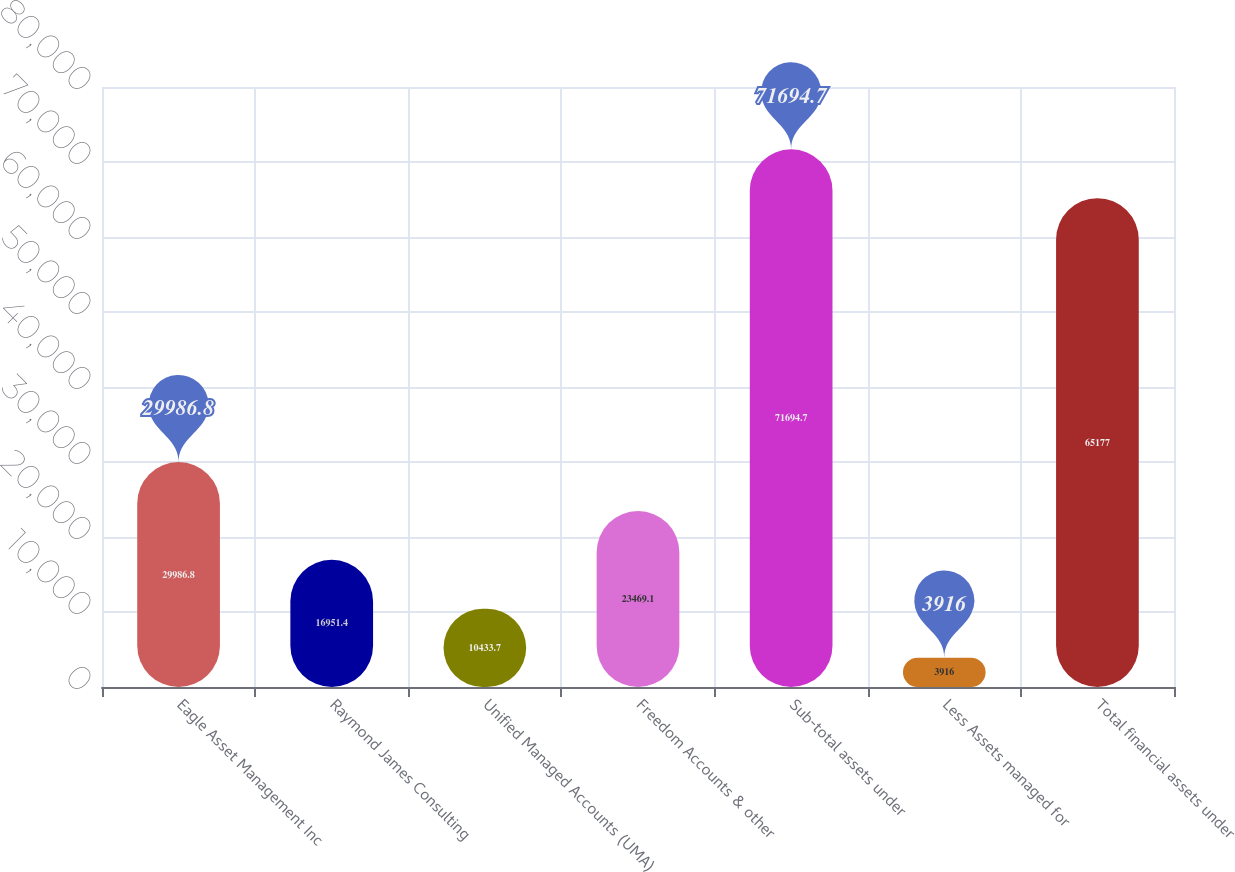<chart> <loc_0><loc_0><loc_500><loc_500><bar_chart><fcel>Eagle Asset Management Inc<fcel>Raymond James Consulting<fcel>Unified Managed Accounts (UMA)<fcel>Freedom Accounts & other<fcel>Sub-total assets under<fcel>Less Assets managed for<fcel>Total financial assets under<nl><fcel>29986.8<fcel>16951.4<fcel>10433.7<fcel>23469.1<fcel>71694.7<fcel>3916<fcel>65177<nl></chart> 